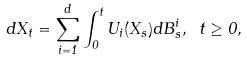Convert formula to latex. <formula><loc_0><loc_0><loc_500><loc_500>d X _ { t } = \sum _ { i = 1 } ^ { d } \int _ { 0 } ^ { t } U _ { i } ( X _ { s } ) d B ^ { i } _ { s } , \text { } t \geq 0 ,</formula> 